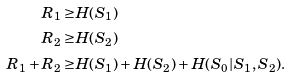<formula> <loc_0><loc_0><loc_500><loc_500>R _ { 1 } \geq & H ( S _ { 1 } ) \\ R _ { 2 } \geq & H ( S _ { 2 } ) \\ R _ { 1 } + R _ { 2 } \geq & H ( S _ { 1 } ) + H ( S _ { 2 } ) + H ( S _ { 0 } | S _ { 1 } , S _ { 2 } ) .</formula> 